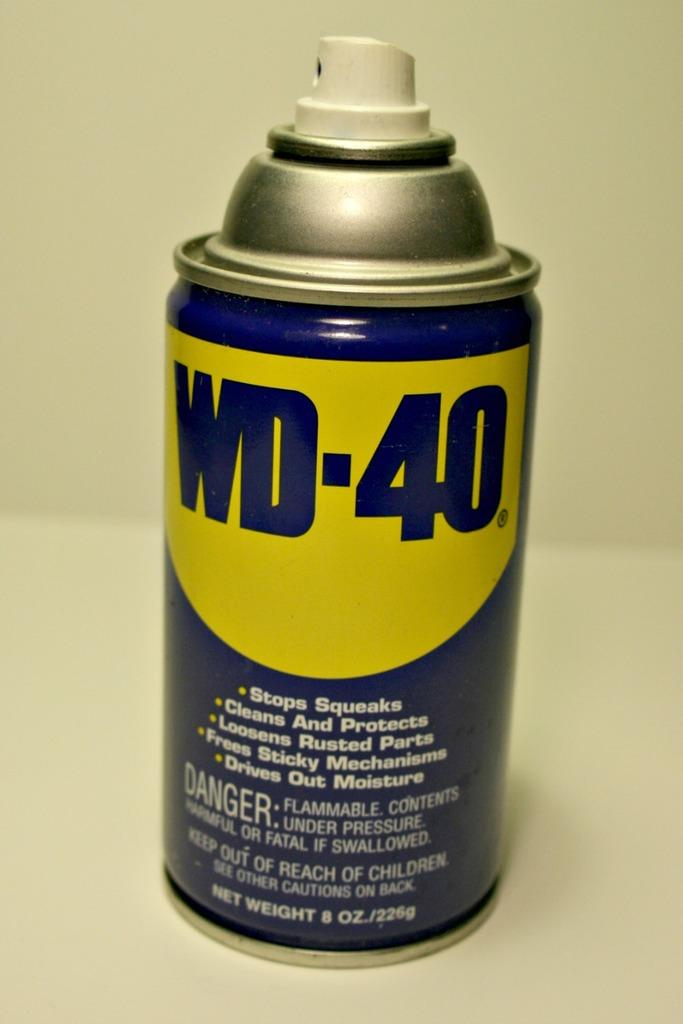What is the main subject of the image? The main subject of the image is a spray tan. Are there any additional features on the spray tan? Yes, there is text on the spray tan. What color is the text on the spray tan? The text is in blue color. What can be seen in the background of the image? There is a wall in the background of the image. How many giraffes can be seen in the image? There are no giraffes present in the image. Is there a volcano visible in the background of the image? There is no volcano visible in the image; it features a wall in the background. 